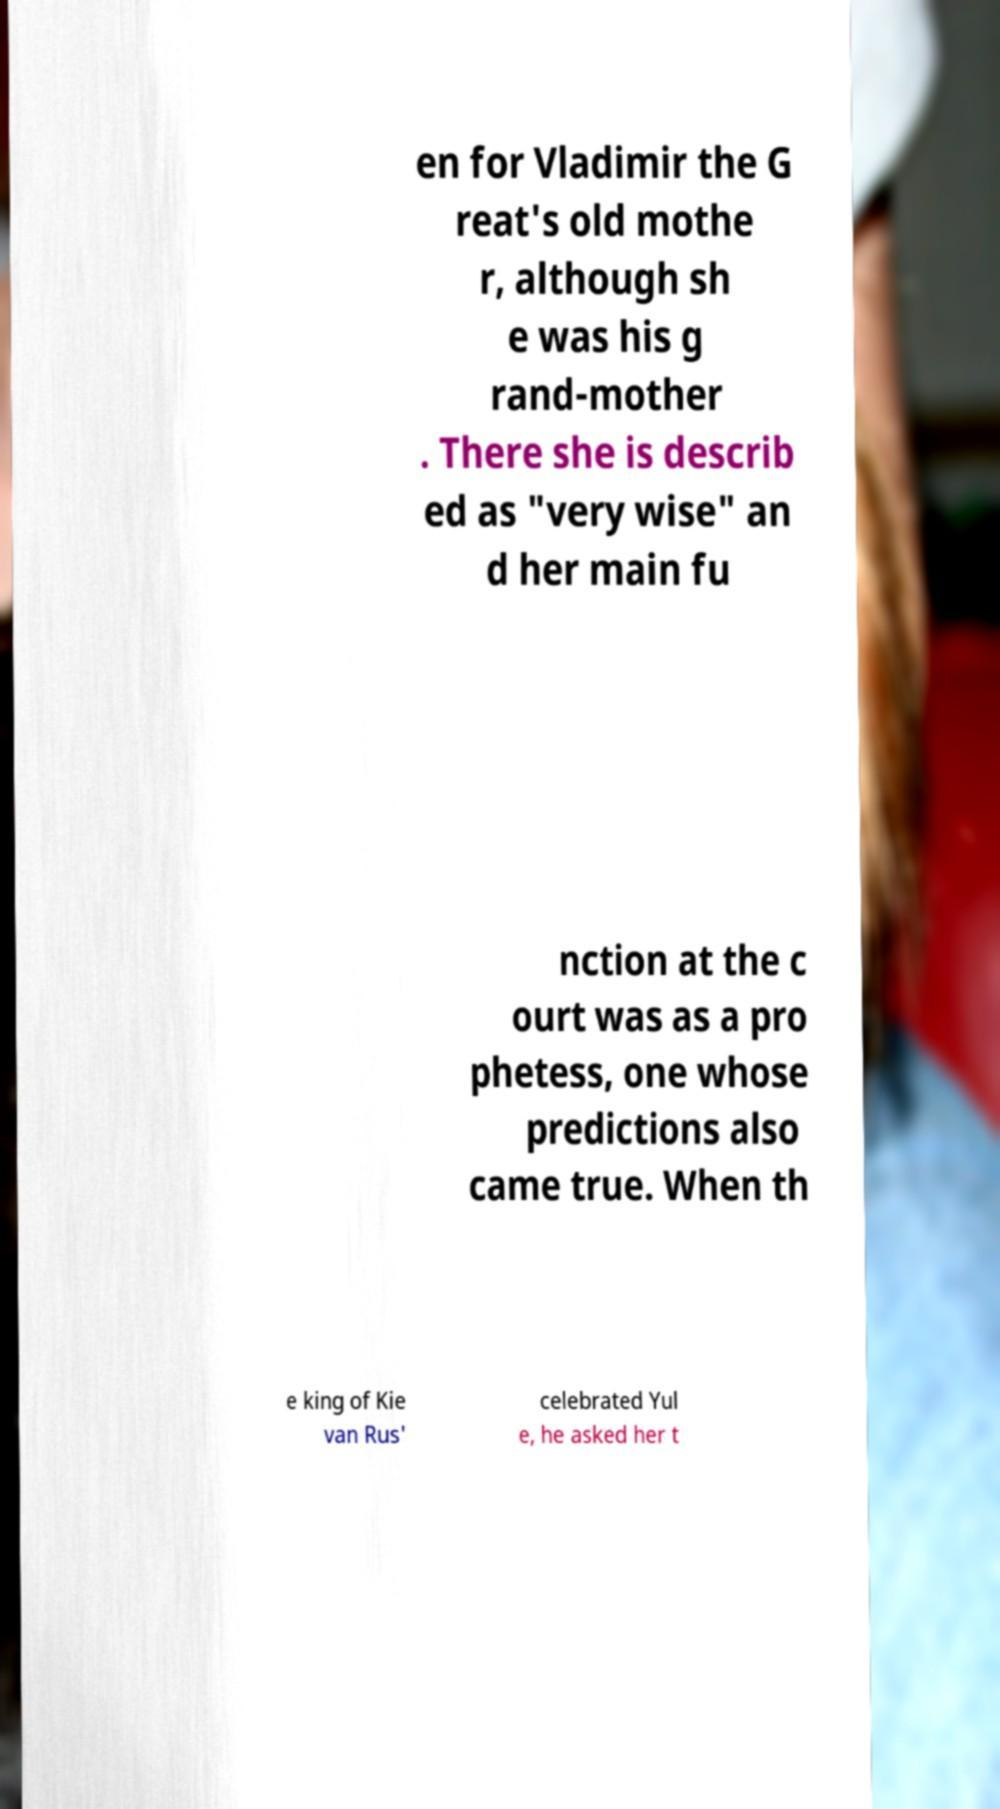I need the written content from this picture converted into text. Can you do that? en for Vladimir the G reat's old mothe r, although sh e was his g rand-mother . There she is describ ed as "very wise" an d her main fu nction at the c ourt was as a pro phetess, one whose predictions also came true. When th e king of Kie van Rus' celebrated Yul e, he asked her t 